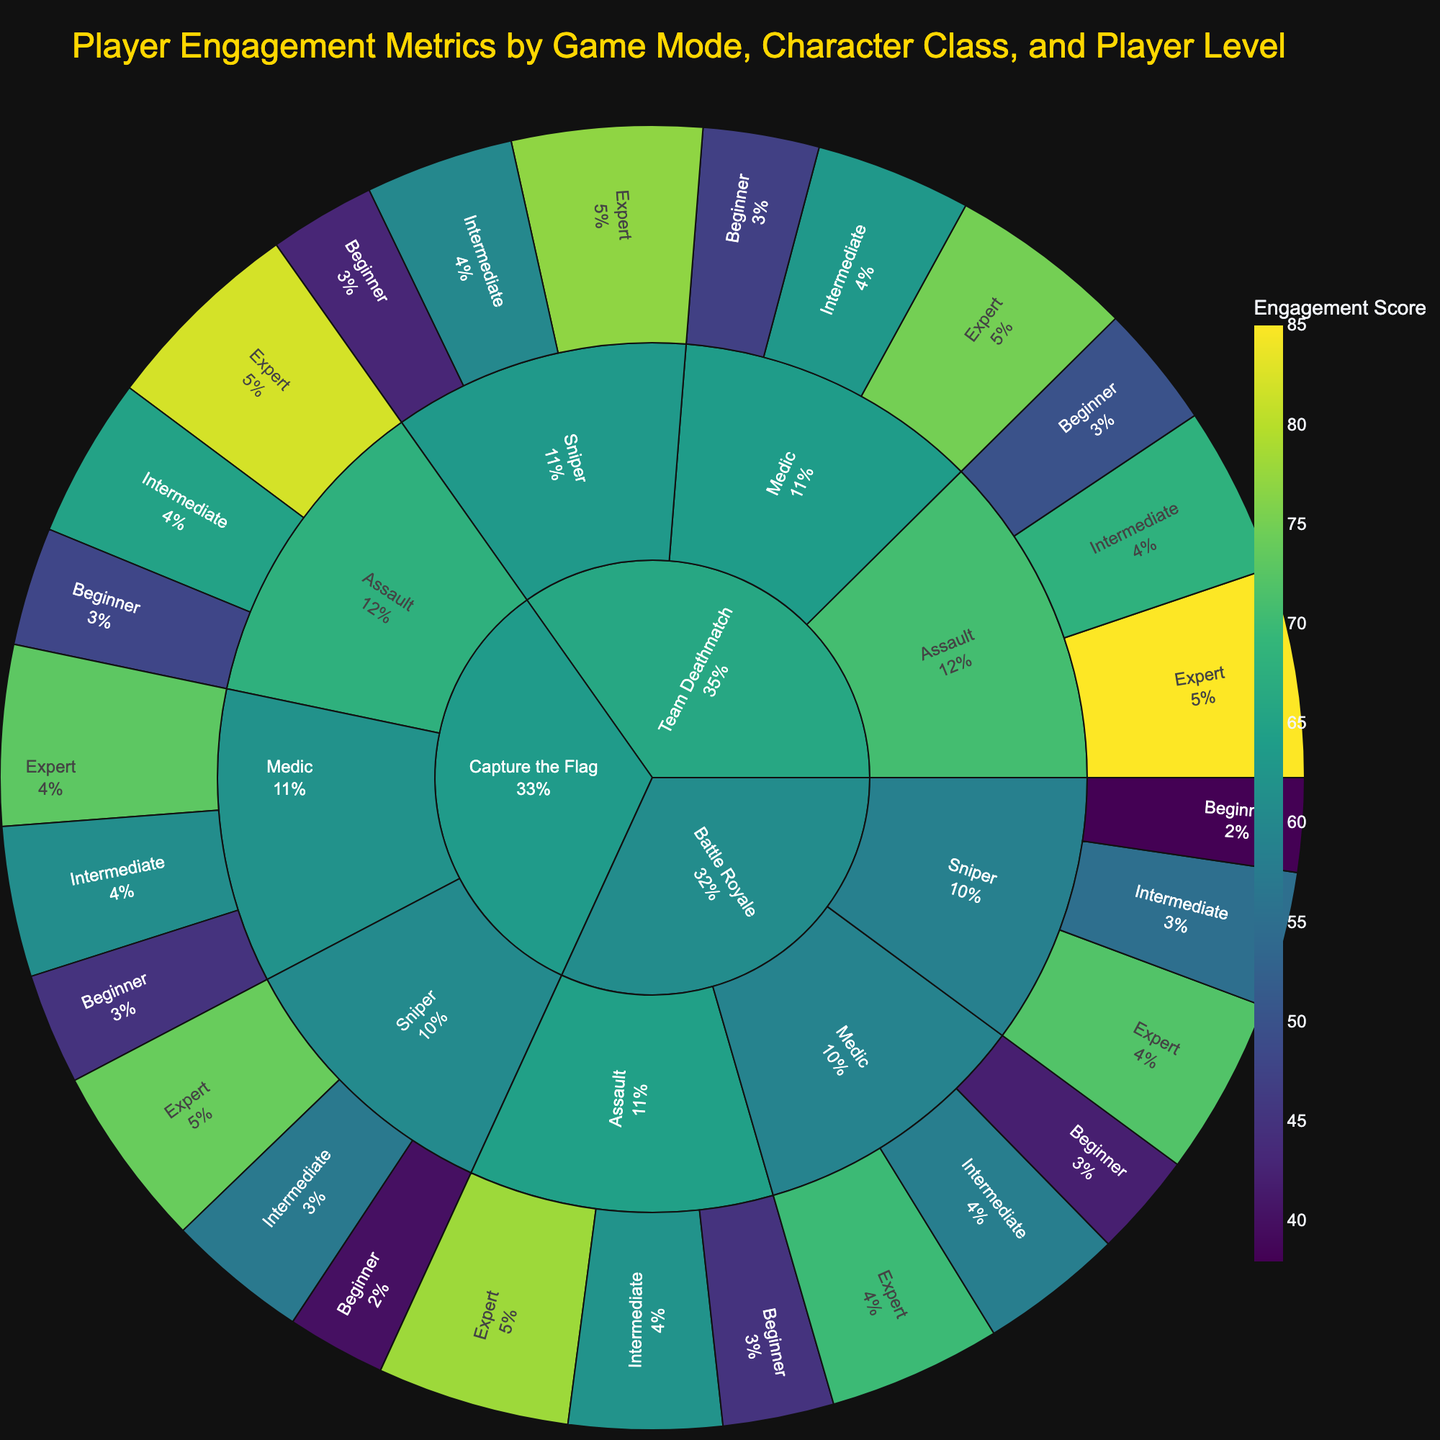What is the color scheme used in the Sunburst Plot? The Sunburst Plot uses a "Viridis" color scheme, which is a continuous color scale ranging from dark to light. This color scheme helps to distinguish between different levels of engagement scores within the game.
Answer: Viridis Which game mode shows the highest engagement score for an Expert level Assault character? To find this, look for the game mode section, then drill down to the Assault character class, and finally, check the Expert level for the highest engagement score. The highest engagement score for an Expert level Assault character is in Team Deathmatch.
Answer: Team Deathmatch What is the title of the Sunburst Plot? The title is located at the top of the Sunburst Plot and reads "Player Engagement Metrics by Game Mode, Character Class, and Player Level."
Answer: Player Engagement Metrics by Game Mode, Character Class, and Player Level How does the engagement score for Intermediate Sniper players compare between Capture the Flag and Team Deathmatch? Compare the engagement scores for Intermediate Sniper players in each game mode. Capture the Flag has an engagement score of 57, while Team Deathmatch has 60. So, Team Deathmatch has a higher engagement score for this category.
Answer: Team Deathmatch is higher What is the median engagement score for Assault characters across all game modes and player levels? To calculate the median, list the engagement scores for Assault characters: 45, 50, 48 (Beginner); 62, 68, 65 (Intermediate); 78, 85, 82 (Expert). The sorted scores are 45, 48, 50, 62, 65, 68, 78, 82, 85. The median is the middle score, which is 65.
Answer: 65 Which character class has the lowest engagement score in Battle Royale mode? In Battle Royale mode, compare the engagement scores of different character classes. Assault (45), Sniper (38), Medic (42). Sniper has the lowest engagement score.
Answer: Sniper What percentage of total engagement does Team Deathmatch contribute for Medic characters at the Expert level? Find the engagement scores for Expert level Medics in all game modes: Battle Royale (70), Team Deathmatch (75), Capture the Flag (73). Calculate the total score (70 + 75 + 73 = 218). Team Deathmatch's contribution is (75/218) * 100 ≈ 34.4%.
Answer: 34.4% Which game mode has the most balanced engagement scores across all character classes and player levels? Look for a game mode where the engagement scores are relatively close to each other irrespective of class and level. Capture the Flag appears balanced with scores ranging from 40 to 82.
Answer: Capture the Flag Which player level has the highest variance in engagement scores for Sniper characters in Battle Royale mode? List the engagement scores for Sniper characters in Battle Royale: Beginner (38), Intermediate (55), Expert (72). Calculate the variance: Mean = (38+55+72)/3 ≈ 55, Variance = [(38-55)^2 + (55-55)^2 + (72-55)^2]/3 ≈ 154.67. So, Expert level has the highest variance.
Answer: Expert 